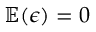Convert formula to latex. <formula><loc_0><loc_0><loc_500><loc_500>\mathbb { E } ( \epsilon ) = 0</formula> 